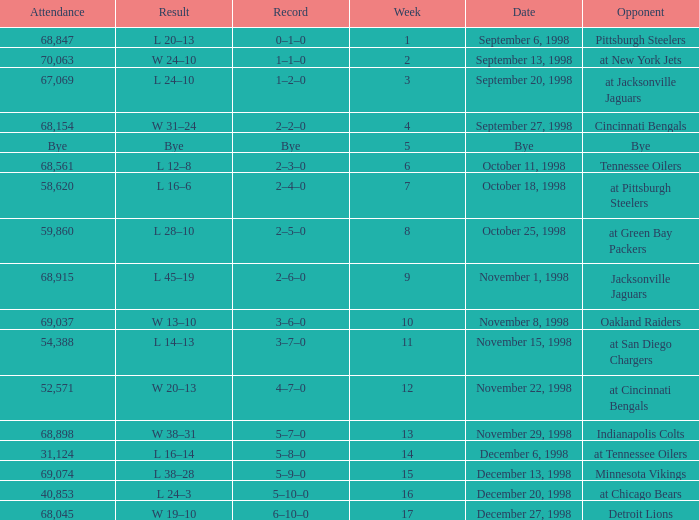Which opponent was played in Week 6? Tennessee Oilers. 